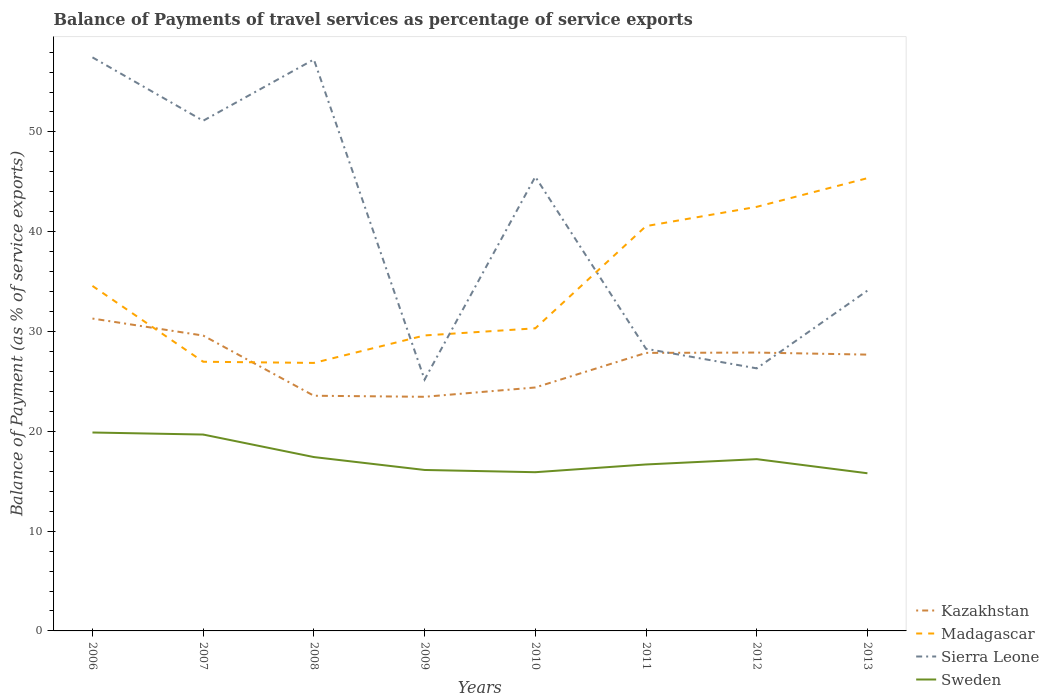How many different coloured lines are there?
Your response must be concise. 4. Across all years, what is the maximum balance of payments of travel services in Sweden?
Give a very brief answer. 15.8. What is the total balance of payments of travel services in Madagascar in the graph?
Ensure brevity in your answer.  -5.99. What is the difference between the highest and the second highest balance of payments of travel services in Kazakhstan?
Your response must be concise. 7.84. What is the difference between the highest and the lowest balance of payments of travel services in Sierra Leone?
Offer a very short reply. 4. Is the balance of payments of travel services in Sweden strictly greater than the balance of payments of travel services in Sierra Leone over the years?
Your response must be concise. Yes. How many lines are there?
Offer a very short reply. 4. What is the difference between two consecutive major ticks on the Y-axis?
Your response must be concise. 10. Are the values on the major ticks of Y-axis written in scientific E-notation?
Provide a short and direct response. No. Where does the legend appear in the graph?
Provide a succinct answer. Bottom right. How are the legend labels stacked?
Keep it short and to the point. Vertical. What is the title of the graph?
Offer a very short reply. Balance of Payments of travel services as percentage of service exports. What is the label or title of the Y-axis?
Your answer should be compact. Balance of Payment (as % of service exports). What is the Balance of Payment (as % of service exports) in Kazakhstan in 2006?
Keep it short and to the point. 31.3. What is the Balance of Payment (as % of service exports) of Madagascar in 2006?
Provide a short and direct response. 34.57. What is the Balance of Payment (as % of service exports) in Sierra Leone in 2006?
Ensure brevity in your answer.  57.47. What is the Balance of Payment (as % of service exports) in Sweden in 2006?
Give a very brief answer. 19.88. What is the Balance of Payment (as % of service exports) in Kazakhstan in 2007?
Ensure brevity in your answer.  29.6. What is the Balance of Payment (as % of service exports) of Madagascar in 2007?
Keep it short and to the point. 26.97. What is the Balance of Payment (as % of service exports) of Sierra Leone in 2007?
Your answer should be compact. 51.12. What is the Balance of Payment (as % of service exports) in Sweden in 2007?
Provide a short and direct response. 19.68. What is the Balance of Payment (as % of service exports) in Kazakhstan in 2008?
Ensure brevity in your answer.  23.57. What is the Balance of Payment (as % of service exports) of Madagascar in 2008?
Offer a terse response. 26.86. What is the Balance of Payment (as % of service exports) in Sierra Leone in 2008?
Your answer should be very brief. 57.26. What is the Balance of Payment (as % of service exports) of Sweden in 2008?
Offer a very short reply. 17.42. What is the Balance of Payment (as % of service exports) of Kazakhstan in 2009?
Your answer should be compact. 23.46. What is the Balance of Payment (as % of service exports) in Madagascar in 2009?
Offer a terse response. 29.61. What is the Balance of Payment (as % of service exports) in Sierra Leone in 2009?
Offer a very short reply. 25.19. What is the Balance of Payment (as % of service exports) of Sweden in 2009?
Your response must be concise. 16.13. What is the Balance of Payment (as % of service exports) of Kazakhstan in 2010?
Make the answer very short. 24.39. What is the Balance of Payment (as % of service exports) of Madagascar in 2010?
Keep it short and to the point. 30.32. What is the Balance of Payment (as % of service exports) of Sierra Leone in 2010?
Provide a succinct answer. 45.51. What is the Balance of Payment (as % of service exports) of Sweden in 2010?
Your answer should be very brief. 15.9. What is the Balance of Payment (as % of service exports) of Kazakhstan in 2011?
Ensure brevity in your answer.  27.86. What is the Balance of Payment (as % of service exports) in Madagascar in 2011?
Provide a short and direct response. 40.56. What is the Balance of Payment (as % of service exports) of Sierra Leone in 2011?
Your answer should be compact. 28.27. What is the Balance of Payment (as % of service exports) of Sweden in 2011?
Your answer should be very brief. 16.68. What is the Balance of Payment (as % of service exports) in Kazakhstan in 2012?
Provide a short and direct response. 27.89. What is the Balance of Payment (as % of service exports) in Madagascar in 2012?
Ensure brevity in your answer.  42.5. What is the Balance of Payment (as % of service exports) of Sierra Leone in 2012?
Give a very brief answer. 26.31. What is the Balance of Payment (as % of service exports) of Sweden in 2012?
Your answer should be compact. 17.21. What is the Balance of Payment (as % of service exports) in Kazakhstan in 2013?
Your response must be concise. 27.69. What is the Balance of Payment (as % of service exports) of Madagascar in 2013?
Keep it short and to the point. 45.37. What is the Balance of Payment (as % of service exports) of Sierra Leone in 2013?
Offer a terse response. 34.1. What is the Balance of Payment (as % of service exports) in Sweden in 2013?
Provide a short and direct response. 15.8. Across all years, what is the maximum Balance of Payment (as % of service exports) in Kazakhstan?
Offer a terse response. 31.3. Across all years, what is the maximum Balance of Payment (as % of service exports) of Madagascar?
Provide a short and direct response. 45.37. Across all years, what is the maximum Balance of Payment (as % of service exports) in Sierra Leone?
Give a very brief answer. 57.47. Across all years, what is the maximum Balance of Payment (as % of service exports) of Sweden?
Offer a terse response. 19.88. Across all years, what is the minimum Balance of Payment (as % of service exports) in Kazakhstan?
Your response must be concise. 23.46. Across all years, what is the minimum Balance of Payment (as % of service exports) of Madagascar?
Make the answer very short. 26.86. Across all years, what is the minimum Balance of Payment (as % of service exports) of Sierra Leone?
Provide a succinct answer. 25.19. Across all years, what is the minimum Balance of Payment (as % of service exports) in Sweden?
Your answer should be compact. 15.8. What is the total Balance of Payment (as % of service exports) of Kazakhstan in the graph?
Your response must be concise. 215.76. What is the total Balance of Payment (as % of service exports) in Madagascar in the graph?
Your response must be concise. 276.76. What is the total Balance of Payment (as % of service exports) in Sierra Leone in the graph?
Your answer should be compact. 325.24. What is the total Balance of Payment (as % of service exports) in Sweden in the graph?
Provide a short and direct response. 138.71. What is the difference between the Balance of Payment (as % of service exports) in Kazakhstan in 2006 and that in 2007?
Keep it short and to the point. 1.7. What is the difference between the Balance of Payment (as % of service exports) of Madagascar in 2006 and that in 2007?
Keep it short and to the point. 7.6. What is the difference between the Balance of Payment (as % of service exports) of Sierra Leone in 2006 and that in 2007?
Provide a succinct answer. 6.35. What is the difference between the Balance of Payment (as % of service exports) in Sweden in 2006 and that in 2007?
Your answer should be compact. 0.2. What is the difference between the Balance of Payment (as % of service exports) in Kazakhstan in 2006 and that in 2008?
Provide a succinct answer. 7.73. What is the difference between the Balance of Payment (as % of service exports) in Madagascar in 2006 and that in 2008?
Offer a terse response. 7.72. What is the difference between the Balance of Payment (as % of service exports) in Sierra Leone in 2006 and that in 2008?
Your response must be concise. 0.21. What is the difference between the Balance of Payment (as % of service exports) in Sweden in 2006 and that in 2008?
Offer a terse response. 2.46. What is the difference between the Balance of Payment (as % of service exports) of Kazakhstan in 2006 and that in 2009?
Provide a succinct answer. 7.84. What is the difference between the Balance of Payment (as % of service exports) of Madagascar in 2006 and that in 2009?
Your answer should be compact. 4.96. What is the difference between the Balance of Payment (as % of service exports) of Sierra Leone in 2006 and that in 2009?
Offer a terse response. 32.29. What is the difference between the Balance of Payment (as % of service exports) in Sweden in 2006 and that in 2009?
Your answer should be compact. 3.75. What is the difference between the Balance of Payment (as % of service exports) of Kazakhstan in 2006 and that in 2010?
Offer a very short reply. 6.91. What is the difference between the Balance of Payment (as % of service exports) in Madagascar in 2006 and that in 2010?
Provide a short and direct response. 4.25. What is the difference between the Balance of Payment (as % of service exports) of Sierra Leone in 2006 and that in 2010?
Offer a very short reply. 11.96. What is the difference between the Balance of Payment (as % of service exports) in Sweden in 2006 and that in 2010?
Ensure brevity in your answer.  3.98. What is the difference between the Balance of Payment (as % of service exports) of Kazakhstan in 2006 and that in 2011?
Your answer should be very brief. 3.44. What is the difference between the Balance of Payment (as % of service exports) in Madagascar in 2006 and that in 2011?
Make the answer very short. -5.99. What is the difference between the Balance of Payment (as % of service exports) in Sierra Leone in 2006 and that in 2011?
Your response must be concise. 29.2. What is the difference between the Balance of Payment (as % of service exports) in Sweden in 2006 and that in 2011?
Your response must be concise. 3.2. What is the difference between the Balance of Payment (as % of service exports) of Kazakhstan in 2006 and that in 2012?
Offer a terse response. 3.41. What is the difference between the Balance of Payment (as % of service exports) in Madagascar in 2006 and that in 2012?
Your answer should be compact. -7.92. What is the difference between the Balance of Payment (as % of service exports) in Sierra Leone in 2006 and that in 2012?
Offer a very short reply. 31.16. What is the difference between the Balance of Payment (as % of service exports) of Sweden in 2006 and that in 2012?
Keep it short and to the point. 2.67. What is the difference between the Balance of Payment (as % of service exports) in Kazakhstan in 2006 and that in 2013?
Provide a short and direct response. 3.61. What is the difference between the Balance of Payment (as % of service exports) in Madagascar in 2006 and that in 2013?
Your answer should be very brief. -10.8. What is the difference between the Balance of Payment (as % of service exports) of Sierra Leone in 2006 and that in 2013?
Offer a terse response. 23.37. What is the difference between the Balance of Payment (as % of service exports) in Sweden in 2006 and that in 2013?
Your response must be concise. 4.08. What is the difference between the Balance of Payment (as % of service exports) of Kazakhstan in 2007 and that in 2008?
Offer a terse response. 6.03. What is the difference between the Balance of Payment (as % of service exports) of Madagascar in 2007 and that in 2008?
Provide a short and direct response. 0.12. What is the difference between the Balance of Payment (as % of service exports) in Sierra Leone in 2007 and that in 2008?
Give a very brief answer. -6.14. What is the difference between the Balance of Payment (as % of service exports) in Sweden in 2007 and that in 2008?
Make the answer very short. 2.26. What is the difference between the Balance of Payment (as % of service exports) in Kazakhstan in 2007 and that in 2009?
Your answer should be very brief. 6.14. What is the difference between the Balance of Payment (as % of service exports) in Madagascar in 2007 and that in 2009?
Provide a succinct answer. -2.64. What is the difference between the Balance of Payment (as % of service exports) in Sierra Leone in 2007 and that in 2009?
Make the answer very short. 25.94. What is the difference between the Balance of Payment (as % of service exports) of Sweden in 2007 and that in 2009?
Make the answer very short. 3.55. What is the difference between the Balance of Payment (as % of service exports) in Kazakhstan in 2007 and that in 2010?
Offer a terse response. 5.2. What is the difference between the Balance of Payment (as % of service exports) of Madagascar in 2007 and that in 2010?
Keep it short and to the point. -3.35. What is the difference between the Balance of Payment (as % of service exports) in Sierra Leone in 2007 and that in 2010?
Ensure brevity in your answer.  5.61. What is the difference between the Balance of Payment (as % of service exports) of Sweden in 2007 and that in 2010?
Offer a very short reply. 3.77. What is the difference between the Balance of Payment (as % of service exports) in Kazakhstan in 2007 and that in 2011?
Ensure brevity in your answer.  1.74. What is the difference between the Balance of Payment (as % of service exports) in Madagascar in 2007 and that in 2011?
Give a very brief answer. -13.59. What is the difference between the Balance of Payment (as % of service exports) of Sierra Leone in 2007 and that in 2011?
Provide a short and direct response. 22.85. What is the difference between the Balance of Payment (as % of service exports) in Sweden in 2007 and that in 2011?
Your answer should be very brief. 3. What is the difference between the Balance of Payment (as % of service exports) of Kazakhstan in 2007 and that in 2012?
Your answer should be compact. 1.7. What is the difference between the Balance of Payment (as % of service exports) of Madagascar in 2007 and that in 2012?
Provide a short and direct response. -15.52. What is the difference between the Balance of Payment (as % of service exports) of Sierra Leone in 2007 and that in 2012?
Provide a succinct answer. 24.81. What is the difference between the Balance of Payment (as % of service exports) in Sweden in 2007 and that in 2012?
Keep it short and to the point. 2.47. What is the difference between the Balance of Payment (as % of service exports) of Kazakhstan in 2007 and that in 2013?
Offer a very short reply. 1.91. What is the difference between the Balance of Payment (as % of service exports) in Madagascar in 2007 and that in 2013?
Your response must be concise. -18.4. What is the difference between the Balance of Payment (as % of service exports) in Sierra Leone in 2007 and that in 2013?
Provide a succinct answer. 17.02. What is the difference between the Balance of Payment (as % of service exports) in Sweden in 2007 and that in 2013?
Make the answer very short. 3.88. What is the difference between the Balance of Payment (as % of service exports) of Kazakhstan in 2008 and that in 2009?
Ensure brevity in your answer.  0.11. What is the difference between the Balance of Payment (as % of service exports) of Madagascar in 2008 and that in 2009?
Provide a short and direct response. -2.75. What is the difference between the Balance of Payment (as % of service exports) in Sierra Leone in 2008 and that in 2009?
Your answer should be compact. 32.08. What is the difference between the Balance of Payment (as % of service exports) of Sweden in 2008 and that in 2009?
Your answer should be very brief. 1.29. What is the difference between the Balance of Payment (as % of service exports) of Kazakhstan in 2008 and that in 2010?
Offer a very short reply. -0.83. What is the difference between the Balance of Payment (as % of service exports) in Madagascar in 2008 and that in 2010?
Provide a succinct answer. -3.47. What is the difference between the Balance of Payment (as % of service exports) in Sierra Leone in 2008 and that in 2010?
Provide a succinct answer. 11.75. What is the difference between the Balance of Payment (as % of service exports) of Sweden in 2008 and that in 2010?
Provide a succinct answer. 1.52. What is the difference between the Balance of Payment (as % of service exports) in Kazakhstan in 2008 and that in 2011?
Your answer should be compact. -4.29. What is the difference between the Balance of Payment (as % of service exports) of Madagascar in 2008 and that in 2011?
Your answer should be compact. -13.71. What is the difference between the Balance of Payment (as % of service exports) in Sierra Leone in 2008 and that in 2011?
Give a very brief answer. 28.99. What is the difference between the Balance of Payment (as % of service exports) in Sweden in 2008 and that in 2011?
Ensure brevity in your answer.  0.74. What is the difference between the Balance of Payment (as % of service exports) in Kazakhstan in 2008 and that in 2012?
Keep it short and to the point. -4.33. What is the difference between the Balance of Payment (as % of service exports) of Madagascar in 2008 and that in 2012?
Provide a succinct answer. -15.64. What is the difference between the Balance of Payment (as % of service exports) of Sierra Leone in 2008 and that in 2012?
Your answer should be very brief. 30.95. What is the difference between the Balance of Payment (as % of service exports) of Sweden in 2008 and that in 2012?
Your response must be concise. 0.21. What is the difference between the Balance of Payment (as % of service exports) of Kazakhstan in 2008 and that in 2013?
Provide a succinct answer. -4.12. What is the difference between the Balance of Payment (as % of service exports) of Madagascar in 2008 and that in 2013?
Give a very brief answer. -18.51. What is the difference between the Balance of Payment (as % of service exports) of Sierra Leone in 2008 and that in 2013?
Provide a succinct answer. 23.16. What is the difference between the Balance of Payment (as % of service exports) in Sweden in 2008 and that in 2013?
Make the answer very short. 1.62. What is the difference between the Balance of Payment (as % of service exports) in Kazakhstan in 2009 and that in 2010?
Ensure brevity in your answer.  -0.93. What is the difference between the Balance of Payment (as % of service exports) of Madagascar in 2009 and that in 2010?
Make the answer very short. -0.71. What is the difference between the Balance of Payment (as % of service exports) of Sierra Leone in 2009 and that in 2010?
Keep it short and to the point. -20.33. What is the difference between the Balance of Payment (as % of service exports) of Sweden in 2009 and that in 2010?
Give a very brief answer. 0.22. What is the difference between the Balance of Payment (as % of service exports) of Kazakhstan in 2009 and that in 2011?
Keep it short and to the point. -4.4. What is the difference between the Balance of Payment (as % of service exports) in Madagascar in 2009 and that in 2011?
Give a very brief answer. -10.96. What is the difference between the Balance of Payment (as % of service exports) of Sierra Leone in 2009 and that in 2011?
Ensure brevity in your answer.  -3.09. What is the difference between the Balance of Payment (as % of service exports) of Sweden in 2009 and that in 2011?
Keep it short and to the point. -0.55. What is the difference between the Balance of Payment (as % of service exports) in Kazakhstan in 2009 and that in 2012?
Offer a terse response. -4.43. What is the difference between the Balance of Payment (as % of service exports) of Madagascar in 2009 and that in 2012?
Your response must be concise. -12.89. What is the difference between the Balance of Payment (as % of service exports) of Sierra Leone in 2009 and that in 2012?
Your response must be concise. -1.13. What is the difference between the Balance of Payment (as % of service exports) of Sweden in 2009 and that in 2012?
Your answer should be very brief. -1.08. What is the difference between the Balance of Payment (as % of service exports) in Kazakhstan in 2009 and that in 2013?
Give a very brief answer. -4.23. What is the difference between the Balance of Payment (as % of service exports) of Madagascar in 2009 and that in 2013?
Your answer should be very brief. -15.76. What is the difference between the Balance of Payment (as % of service exports) of Sierra Leone in 2009 and that in 2013?
Your response must be concise. -8.92. What is the difference between the Balance of Payment (as % of service exports) in Sweden in 2009 and that in 2013?
Your answer should be compact. 0.33. What is the difference between the Balance of Payment (as % of service exports) in Kazakhstan in 2010 and that in 2011?
Ensure brevity in your answer.  -3.47. What is the difference between the Balance of Payment (as % of service exports) in Madagascar in 2010 and that in 2011?
Keep it short and to the point. -10.24. What is the difference between the Balance of Payment (as % of service exports) of Sierra Leone in 2010 and that in 2011?
Ensure brevity in your answer.  17.24. What is the difference between the Balance of Payment (as % of service exports) of Sweden in 2010 and that in 2011?
Your answer should be very brief. -0.78. What is the difference between the Balance of Payment (as % of service exports) in Kazakhstan in 2010 and that in 2012?
Your response must be concise. -3.5. What is the difference between the Balance of Payment (as % of service exports) in Madagascar in 2010 and that in 2012?
Your answer should be compact. -12.17. What is the difference between the Balance of Payment (as % of service exports) in Sierra Leone in 2010 and that in 2012?
Keep it short and to the point. 19.2. What is the difference between the Balance of Payment (as % of service exports) in Sweden in 2010 and that in 2012?
Offer a very short reply. -1.31. What is the difference between the Balance of Payment (as % of service exports) of Kazakhstan in 2010 and that in 2013?
Provide a short and direct response. -3.29. What is the difference between the Balance of Payment (as % of service exports) in Madagascar in 2010 and that in 2013?
Give a very brief answer. -15.05. What is the difference between the Balance of Payment (as % of service exports) of Sierra Leone in 2010 and that in 2013?
Provide a short and direct response. 11.41. What is the difference between the Balance of Payment (as % of service exports) of Sweden in 2010 and that in 2013?
Make the answer very short. 0.11. What is the difference between the Balance of Payment (as % of service exports) in Kazakhstan in 2011 and that in 2012?
Give a very brief answer. -0.03. What is the difference between the Balance of Payment (as % of service exports) in Madagascar in 2011 and that in 2012?
Offer a very short reply. -1.93. What is the difference between the Balance of Payment (as % of service exports) in Sierra Leone in 2011 and that in 2012?
Give a very brief answer. 1.96. What is the difference between the Balance of Payment (as % of service exports) of Sweden in 2011 and that in 2012?
Your response must be concise. -0.53. What is the difference between the Balance of Payment (as % of service exports) in Kazakhstan in 2011 and that in 2013?
Give a very brief answer. 0.17. What is the difference between the Balance of Payment (as % of service exports) in Madagascar in 2011 and that in 2013?
Provide a succinct answer. -4.8. What is the difference between the Balance of Payment (as % of service exports) of Sierra Leone in 2011 and that in 2013?
Offer a terse response. -5.83. What is the difference between the Balance of Payment (as % of service exports) in Sweden in 2011 and that in 2013?
Keep it short and to the point. 0.88. What is the difference between the Balance of Payment (as % of service exports) of Kazakhstan in 2012 and that in 2013?
Your answer should be very brief. 0.21. What is the difference between the Balance of Payment (as % of service exports) in Madagascar in 2012 and that in 2013?
Offer a terse response. -2.87. What is the difference between the Balance of Payment (as % of service exports) in Sierra Leone in 2012 and that in 2013?
Your response must be concise. -7.79. What is the difference between the Balance of Payment (as % of service exports) of Sweden in 2012 and that in 2013?
Make the answer very short. 1.41. What is the difference between the Balance of Payment (as % of service exports) of Kazakhstan in 2006 and the Balance of Payment (as % of service exports) of Madagascar in 2007?
Offer a terse response. 4.33. What is the difference between the Balance of Payment (as % of service exports) of Kazakhstan in 2006 and the Balance of Payment (as % of service exports) of Sierra Leone in 2007?
Offer a very short reply. -19.82. What is the difference between the Balance of Payment (as % of service exports) in Kazakhstan in 2006 and the Balance of Payment (as % of service exports) in Sweden in 2007?
Offer a very short reply. 11.62. What is the difference between the Balance of Payment (as % of service exports) in Madagascar in 2006 and the Balance of Payment (as % of service exports) in Sierra Leone in 2007?
Your answer should be compact. -16.55. What is the difference between the Balance of Payment (as % of service exports) of Madagascar in 2006 and the Balance of Payment (as % of service exports) of Sweden in 2007?
Provide a succinct answer. 14.89. What is the difference between the Balance of Payment (as % of service exports) in Sierra Leone in 2006 and the Balance of Payment (as % of service exports) in Sweden in 2007?
Your response must be concise. 37.79. What is the difference between the Balance of Payment (as % of service exports) in Kazakhstan in 2006 and the Balance of Payment (as % of service exports) in Madagascar in 2008?
Give a very brief answer. 4.45. What is the difference between the Balance of Payment (as % of service exports) in Kazakhstan in 2006 and the Balance of Payment (as % of service exports) in Sierra Leone in 2008?
Ensure brevity in your answer.  -25.96. What is the difference between the Balance of Payment (as % of service exports) of Kazakhstan in 2006 and the Balance of Payment (as % of service exports) of Sweden in 2008?
Offer a very short reply. 13.88. What is the difference between the Balance of Payment (as % of service exports) in Madagascar in 2006 and the Balance of Payment (as % of service exports) in Sierra Leone in 2008?
Make the answer very short. -22.69. What is the difference between the Balance of Payment (as % of service exports) in Madagascar in 2006 and the Balance of Payment (as % of service exports) in Sweden in 2008?
Your response must be concise. 17.15. What is the difference between the Balance of Payment (as % of service exports) in Sierra Leone in 2006 and the Balance of Payment (as % of service exports) in Sweden in 2008?
Your response must be concise. 40.05. What is the difference between the Balance of Payment (as % of service exports) in Kazakhstan in 2006 and the Balance of Payment (as % of service exports) in Madagascar in 2009?
Give a very brief answer. 1.69. What is the difference between the Balance of Payment (as % of service exports) of Kazakhstan in 2006 and the Balance of Payment (as % of service exports) of Sierra Leone in 2009?
Your answer should be compact. 6.12. What is the difference between the Balance of Payment (as % of service exports) in Kazakhstan in 2006 and the Balance of Payment (as % of service exports) in Sweden in 2009?
Your answer should be very brief. 15.17. What is the difference between the Balance of Payment (as % of service exports) of Madagascar in 2006 and the Balance of Payment (as % of service exports) of Sierra Leone in 2009?
Provide a short and direct response. 9.39. What is the difference between the Balance of Payment (as % of service exports) of Madagascar in 2006 and the Balance of Payment (as % of service exports) of Sweden in 2009?
Offer a very short reply. 18.44. What is the difference between the Balance of Payment (as % of service exports) in Sierra Leone in 2006 and the Balance of Payment (as % of service exports) in Sweden in 2009?
Your answer should be compact. 41.34. What is the difference between the Balance of Payment (as % of service exports) of Kazakhstan in 2006 and the Balance of Payment (as % of service exports) of Madagascar in 2010?
Your response must be concise. 0.98. What is the difference between the Balance of Payment (as % of service exports) in Kazakhstan in 2006 and the Balance of Payment (as % of service exports) in Sierra Leone in 2010?
Ensure brevity in your answer.  -14.21. What is the difference between the Balance of Payment (as % of service exports) in Kazakhstan in 2006 and the Balance of Payment (as % of service exports) in Sweden in 2010?
Offer a very short reply. 15.4. What is the difference between the Balance of Payment (as % of service exports) of Madagascar in 2006 and the Balance of Payment (as % of service exports) of Sierra Leone in 2010?
Offer a very short reply. -10.94. What is the difference between the Balance of Payment (as % of service exports) of Madagascar in 2006 and the Balance of Payment (as % of service exports) of Sweden in 2010?
Provide a short and direct response. 18.67. What is the difference between the Balance of Payment (as % of service exports) in Sierra Leone in 2006 and the Balance of Payment (as % of service exports) in Sweden in 2010?
Keep it short and to the point. 41.57. What is the difference between the Balance of Payment (as % of service exports) in Kazakhstan in 2006 and the Balance of Payment (as % of service exports) in Madagascar in 2011?
Offer a very short reply. -9.26. What is the difference between the Balance of Payment (as % of service exports) in Kazakhstan in 2006 and the Balance of Payment (as % of service exports) in Sierra Leone in 2011?
Your answer should be very brief. 3.03. What is the difference between the Balance of Payment (as % of service exports) of Kazakhstan in 2006 and the Balance of Payment (as % of service exports) of Sweden in 2011?
Provide a succinct answer. 14.62. What is the difference between the Balance of Payment (as % of service exports) of Madagascar in 2006 and the Balance of Payment (as % of service exports) of Sierra Leone in 2011?
Offer a terse response. 6.3. What is the difference between the Balance of Payment (as % of service exports) of Madagascar in 2006 and the Balance of Payment (as % of service exports) of Sweden in 2011?
Offer a very short reply. 17.89. What is the difference between the Balance of Payment (as % of service exports) of Sierra Leone in 2006 and the Balance of Payment (as % of service exports) of Sweden in 2011?
Your answer should be compact. 40.79. What is the difference between the Balance of Payment (as % of service exports) in Kazakhstan in 2006 and the Balance of Payment (as % of service exports) in Madagascar in 2012?
Offer a very short reply. -11.19. What is the difference between the Balance of Payment (as % of service exports) of Kazakhstan in 2006 and the Balance of Payment (as % of service exports) of Sierra Leone in 2012?
Ensure brevity in your answer.  4.99. What is the difference between the Balance of Payment (as % of service exports) of Kazakhstan in 2006 and the Balance of Payment (as % of service exports) of Sweden in 2012?
Your answer should be compact. 14.09. What is the difference between the Balance of Payment (as % of service exports) in Madagascar in 2006 and the Balance of Payment (as % of service exports) in Sierra Leone in 2012?
Your answer should be very brief. 8.26. What is the difference between the Balance of Payment (as % of service exports) in Madagascar in 2006 and the Balance of Payment (as % of service exports) in Sweden in 2012?
Provide a succinct answer. 17.36. What is the difference between the Balance of Payment (as % of service exports) of Sierra Leone in 2006 and the Balance of Payment (as % of service exports) of Sweden in 2012?
Give a very brief answer. 40.26. What is the difference between the Balance of Payment (as % of service exports) in Kazakhstan in 2006 and the Balance of Payment (as % of service exports) in Madagascar in 2013?
Give a very brief answer. -14.07. What is the difference between the Balance of Payment (as % of service exports) in Kazakhstan in 2006 and the Balance of Payment (as % of service exports) in Sierra Leone in 2013?
Provide a succinct answer. -2.8. What is the difference between the Balance of Payment (as % of service exports) in Kazakhstan in 2006 and the Balance of Payment (as % of service exports) in Sweden in 2013?
Keep it short and to the point. 15.5. What is the difference between the Balance of Payment (as % of service exports) in Madagascar in 2006 and the Balance of Payment (as % of service exports) in Sierra Leone in 2013?
Make the answer very short. 0.47. What is the difference between the Balance of Payment (as % of service exports) of Madagascar in 2006 and the Balance of Payment (as % of service exports) of Sweden in 2013?
Your response must be concise. 18.77. What is the difference between the Balance of Payment (as % of service exports) of Sierra Leone in 2006 and the Balance of Payment (as % of service exports) of Sweden in 2013?
Make the answer very short. 41.67. What is the difference between the Balance of Payment (as % of service exports) of Kazakhstan in 2007 and the Balance of Payment (as % of service exports) of Madagascar in 2008?
Make the answer very short. 2.74. What is the difference between the Balance of Payment (as % of service exports) of Kazakhstan in 2007 and the Balance of Payment (as % of service exports) of Sierra Leone in 2008?
Make the answer very short. -27.66. What is the difference between the Balance of Payment (as % of service exports) of Kazakhstan in 2007 and the Balance of Payment (as % of service exports) of Sweden in 2008?
Give a very brief answer. 12.18. What is the difference between the Balance of Payment (as % of service exports) in Madagascar in 2007 and the Balance of Payment (as % of service exports) in Sierra Leone in 2008?
Provide a short and direct response. -30.29. What is the difference between the Balance of Payment (as % of service exports) of Madagascar in 2007 and the Balance of Payment (as % of service exports) of Sweden in 2008?
Keep it short and to the point. 9.55. What is the difference between the Balance of Payment (as % of service exports) in Sierra Leone in 2007 and the Balance of Payment (as % of service exports) in Sweden in 2008?
Provide a short and direct response. 33.7. What is the difference between the Balance of Payment (as % of service exports) of Kazakhstan in 2007 and the Balance of Payment (as % of service exports) of Madagascar in 2009?
Offer a very short reply. -0.01. What is the difference between the Balance of Payment (as % of service exports) of Kazakhstan in 2007 and the Balance of Payment (as % of service exports) of Sierra Leone in 2009?
Make the answer very short. 4.41. What is the difference between the Balance of Payment (as % of service exports) of Kazakhstan in 2007 and the Balance of Payment (as % of service exports) of Sweden in 2009?
Your answer should be very brief. 13.47. What is the difference between the Balance of Payment (as % of service exports) of Madagascar in 2007 and the Balance of Payment (as % of service exports) of Sierra Leone in 2009?
Provide a short and direct response. 1.79. What is the difference between the Balance of Payment (as % of service exports) of Madagascar in 2007 and the Balance of Payment (as % of service exports) of Sweden in 2009?
Offer a very short reply. 10.84. What is the difference between the Balance of Payment (as % of service exports) in Sierra Leone in 2007 and the Balance of Payment (as % of service exports) in Sweden in 2009?
Your answer should be compact. 34.99. What is the difference between the Balance of Payment (as % of service exports) in Kazakhstan in 2007 and the Balance of Payment (as % of service exports) in Madagascar in 2010?
Ensure brevity in your answer.  -0.73. What is the difference between the Balance of Payment (as % of service exports) of Kazakhstan in 2007 and the Balance of Payment (as % of service exports) of Sierra Leone in 2010?
Give a very brief answer. -15.91. What is the difference between the Balance of Payment (as % of service exports) of Kazakhstan in 2007 and the Balance of Payment (as % of service exports) of Sweden in 2010?
Give a very brief answer. 13.69. What is the difference between the Balance of Payment (as % of service exports) in Madagascar in 2007 and the Balance of Payment (as % of service exports) in Sierra Leone in 2010?
Offer a very short reply. -18.54. What is the difference between the Balance of Payment (as % of service exports) of Madagascar in 2007 and the Balance of Payment (as % of service exports) of Sweden in 2010?
Keep it short and to the point. 11.07. What is the difference between the Balance of Payment (as % of service exports) of Sierra Leone in 2007 and the Balance of Payment (as % of service exports) of Sweden in 2010?
Offer a terse response. 35.22. What is the difference between the Balance of Payment (as % of service exports) in Kazakhstan in 2007 and the Balance of Payment (as % of service exports) in Madagascar in 2011?
Your answer should be compact. -10.97. What is the difference between the Balance of Payment (as % of service exports) in Kazakhstan in 2007 and the Balance of Payment (as % of service exports) in Sierra Leone in 2011?
Your answer should be compact. 1.33. What is the difference between the Balance of Payment (as % of service exports) of Kazakhstan in 2007 and the Balance of Payment (as % of service exports) of Sweden in 2011?
Provide a short and direct response. 12.92. What is the difference between the Balance of Payment (as % of service exports) in Madagascar in 2007 and the Balance of Payment (as % of service exports) in Sierra Leone in 2011?
Offer a very short reply. -1.3. What is the difference between the Balance of Payment (as % of service exports) of Madagascar in 2007 and the Balance of Payment (as % of service exports) of Sweden in 2011?
Offer a very short reply. 10.29. What is the difference between the Balance of Payment (as % of service exports) in Sierra Leone in 2007 and the Balance of Payment (as % of service exports) in Sweden in 2011?
Your response must be concise. 34.44. What is the difference between the Balance of Payment (as % of service exports) of Kazakhstan in 2007 and the Balance of Payment (as % of service exports) of Madagascar in 2012?
Keep it short and to the point. -12.9. What is the difference between the Balance of Payment (as % of service exports) of Kazakhstan in 2007 and the Balance of Payment (as % of service exports) of Sierra Leone in 2012?
Give a very brief answer. 3.29. What is the difference between the Balance of Payment (as % of service exports) in Kazakhstan in 2007 and the Balance of Payment (as % of service exports) in Sweden in 2012?
Your answer should be very brief. 12.38. What is the difference between the Balance of Payment (as % of service exports) of Madagascar in 2007 and the Balance of Payment (as % of service exports) of Sierra Leone in 2012?
Make the answer very short. 0.66. What is the difference between the Balance of Payment (as % of service exports) in Madagascar in 2007 and the Balance of Payment (as % of service exports) in Sweden in 2012?
Your answer should be very brief. 9.76. What is the difference between the Balance of Payment (as % of service exports) of Sierra Leone in 2007 and the Balance of Payment (as % of service exports) of Sweden in 2012?
Ensure brevity in your answer.  33.91. What is the difference between the Balance of Payment (as % of service exports) of Kazakhstan in 2007 and the Balance of Payment (as % of service exports) of Madagascar in 2013?
Your answer should be compact. -15.77. What is the difference between the Balance of Payment (as % of service exports) of Kazakhstan in 2007 and the Balance of Payment (as % of service exports) of Sierra Leone in 2013?
Your response must be concise. -4.5. What is the difference between the Balance of Payment (as % of service exports) of Kazakhstan in 2007 and the Balance of Payment (as % of service exports) of Sweden in 2013?
Make the answer very short. 13.8. What is the difference between the Balance of Payment (as % of service exports) in Madagascar in 2007 and the Balance of Payment (as % of service exports) in Sierra Leone in 2013?
Your answer should be compact. -7.13. What is the difference between the Balance of Payment (as % of service exports) of Madagascar in 2007 and the Balance of Payment (as % of service exports) of Sweden in 2013?
Make the answer very short. 11.17. What is the difference between the Balance of Payment (as % of service exports) in Sierra Leone in 2007 and the Balance of Payment (as % of service exports) in Sweden in 2013?
Provide a short and direct response. 35.32. What is the difference between the Balance of Payment (as % of service exports) in Kazakhstan in 2008 and the Balance of Payment (as % of service exports) in Madagascar in 2009?
Make the answer very short. -6.04. What is the difference between the Balance of Payment (as % of service exports) of Kazakhstan in 2008 and the Balance of Payment (as % of service exports) of Sierra Leone in 2009?
Ensure brevity in your answer.  -1.62. What is the difference between the Balance of Payment (as % of service exports) of Kazakhstan in 2008 and the Balance of Payment (as % of service exports) of Sweden in 2009?
Offer a terse response. 7.44. What is the difference between the Balance of Payment (as % of service exports) in Madagascar in 2008 and the Balance of Payment (as % of service exports) in Sierra Leone in 2009?
Provide a short and direct response. 1.67. What is the difference between the Balance of Payment (as % of service exports) in Madagascar in 2008 and the Balance of Payment (as % of service exports) in Sweden in 2009?
Your answer should be compact. 10.73. What is the difference between the Balance of Payment (as % of service exports) of Sierra Leone in 2008 and the Balance of Payment (as % of service exports) of Sweden in 2009?
Offer a terse response. 41.13. What is the difference between the Balance of Payment (as % of service exports) of Kazakhstan in 2008 and the Balance of Payment (as % of service exports) of Madagascar in 2010?
Give a very brief answer. -6.76. What is the difference between the Balance of Payment (as % of service exports) in Kazakhstan in 2008 and the Balance of Payment (as % of service exports) in Sierra Leone in 2010?
Your answer should be compact. -21.94. What is the difference between the Balance of Payment (as % of service exports) in Kazakhstan in 2008 and the Balance of Payment (as % of service exports) in Sweden in 2010?
Give a very brief answer. 7.66. What is the difference between the Balance of Payment (as % of service exports) in Madagascar in 2008 and the Balance of Payment (as % of service exports) in Sierra Leone in 2010?
Give a very brief answer. -18.66. What is the difference between the Balance of Payment (as % of service exports) of Madagascar in 2008 and the Balance of Payment (as % of service exports) of Sweden in 2010?
Offer a terse response. 10.95. What is the difference between the Balance of Payment (as % of service exports) in Sierra Leone in 2008 and the Balance of Payment (as % of service exports) in Sweden in 2010?
Keep it short and to the point. 41.36. What is the difference between the Balance of Payment (as % of service exports) of Kazakhstan in 2008 and the Balance of Payment (as % of service exports) of Madagascar in 2011?
Provide a short and direct response. -17. What is the difference between the Balance of Payment (as % of service exports) of Kazakhstan in 2008 and the Balance of Payment (as % of service exports) of Sierra Leone in 2011?
Provide a short and direct response. -4.7. What is the difference between the Balance of Payment (as % of service exports) of Kazakhstan in 2008 and the Balance of Payment (as % of service exports) of Sweden in 2011?
Give a very brief answer. 6.89. What is the difference between the Balance of Payment (as % of service exports) of Madagascar in 2008 and the Balance of Payment (as % of service exports) of Sierra Leone in 2011?
Give a very brief answer. -1.42. What is the difference between the Balance of Payment (as % of service exports) of Madagascar in 2008 and the Balance of Payment (as % of service exports) of Sweden in 2011?
Make the answer very short. 10.18. What is the difference between the Balance of Payment (as % of service exports) of Sierra Leone in 2008 and the Balance of Payment (as % of service exports) of Sweden in 2011?
Make the answer very short. 40.58. What is the difference between the Balance of Payment (as % of service exports) of Kazakhstan in 2008 and the Balance of Payment (as % of service exports) of Madagascar in 2012?
Your response must be concise. -18.93. What is the difference between the Balance of Payment (as % of service exports) of Kazakhstan in 2008 and the Balance of Payment (as % of service exports) of Sierra Leone in 2012?
Provide a succinct answer. -2.75. What is the difference between the Balance of Payment (as % of service exports) in Kazakhstan in 2008 and the Balance of Payment (as % of service exports) in Sweden in 2012?
Ensure brevity in your answer.  6.35. What is the difference between the Balance of Payment (as % of service exports) of Madagascar in 2008 and the Balance of Payment (as % of service exports) of Sierra Leone in 2012?
Provide a succinct answer. 0.54. What is the difference between the Balance of Payment (as % of service exports) of Madagascar in 2008 and the Balance of Payment (as % of service exports) of Sweden in 2012?
Give a very brief answer. 9.64. What is the difference between the Balance of Payment (as % of service exports) in Sierra Leone in 2008 and the Balance of Payment (as % of service exports) in Sweden in 2012?
Provide a short and direct response. 40.05. What is the difference between the Balance of Payment (as % of service exports) of Kazakhstan in 2008 and the Balance of Payment (as % of service exports) of Madagascar in 2013?
Give a very brief answer. -21.8. What is the difference between the Balance of Payment (as % of service exports) of Kazakhstan in 2008 and the Balance of Payment (as % of service exports) of Sierra Leone in 2013?
Your response must be concise. -10.54. What is the difference between the Balance of Payment (as % of service exports) in Kazakhstan in 2008 and the Balance of Payment (as % of service exports) in Sweden in 2013?
Provide a short and direct response. 7.77. What is the difference between the Balance of Payment (as % of service exports) of Madagascar in 2008 and the Balance of Payment (as % of service exports) of Sierra Leone in 2013?
Your answer should be compact. -7.25. What is the difference between the Balance of Payment (as % of service exports) of Madagascar in 2008 and the Balance of Payment (as % of service exports) of Sweden in 2013?
Offer a terse response. 11.06. What is the difference between the Balance of Payment (as % of service exports) of Sierra Leone in 2008 and the Balance of Payment (as % of service exports) of Sweden in 2013?
Keep it short and to the point. 41.46. What is the difference between the Balance of Payment (as % of service exports) of Kazakhstan in 2009 and the Balance of Payment (as % of service exports) of Madagascar in 2010?
Provide a succinct answer. -6.86. What is the difference between the Balance of Payment (as % of service exports) in Kazakhstan in 2009 and the Balance of Payment (as % of service exports) in Sierra Leone in 2010?
Ensure brevity in your answer.  -22.05. What is the difference between the Balance of Payment (as % of service exports) of Kazakhstan in 2009 and the Balance of Payment (as % of service exports) of Sweden in 2010?
Give a very brief answer. 7.56. What is the difference between the Balance of Payment (as % of service exports) in Madagascar in 2009 and the Balance of Payment (as % of service exports) in Sierra Leone in 2010?
Your answer should be very brief. -15.9. What is the difference between the Balance of Payment (as % of service exports) in Madagascar in 2009 and the Balance of Payment (as % of service exports) in Sweden in 2010?
Ensure brevity in your answer.  13.7. What is the difference between the Balance of Payment (as % of service exports) of Sierra Leone in 2009 and the Balance of Payment (as % of service exports) of Sweden in 2010?
Your response must be concise. 9.28. What is the difference between the Balance of Payment (as % of service exports) of Kazakhstan in 2009 and the Balance of Payment (as % of service exports) of Madagascar in 2011?
Your answer should be compact. -17.1. What is the difference between the Balance of Payment (as % of service exports) in Kazakhstan in 2009 and the Balance of Payment (as % of service exports) in Sierra Leone in 2011?
Your answer should be very brief. -4.81. What is the difference between the Balance of Payment (as % of service exports) in Kazakhstan in 2009 and the Balance of Payment (as % of service exports) in Sweden in 2011?
Your response must be concise. 6.78. What is the difference between the Balance of Payment (as % of service exports) of Madagascar in 2009 and the Balance of Payment (as % of service exports) of Sierra Leone in 2011?
Your answer should be very brief. 1.34. What is the difference between the Balance of Payment (as % of service exports) of Madagascar in 2009 and the Balance of Payment (as % of service exports) of Sweden in 2011?
Give a very brief answer. 12.93. What is the difference between the Balance of Payment (as % of service exports) of Sierra Leone in 2009 and the Balance of Payment (as % of service exports) of Sweden in 2011?
Offer a very short reply. 8.51. What is the difference between the Balance of Payment (as % of service exports) of Kazakhstan in 2009 and the Balance of Payment (as % of service exports) of Madagascar in 2012?
Your answer should be very brief. -19.03. What is the difference between the Balance of Payment (as % of service exports) in Kazakhstan in 2009 and the Balance of Payment (as % of service exports) in Sierra Leone in 2012?
Offer a terse response. -2.85. What is the difference between the Balance of Payment (as % of service exports) of Kazakhstan in 2009 and the Balance of Payment (as % of service exports) of Sweden in 2012?
Provide a succinct answer. 6.25. What is the difference between the Balance of Payment (as % of service exports) of Madagascar in 2009 and the Balance of Payment (as % of service exports) of Sierra Leone in 2012?
Ensure brevity in your answer.  3.3. What is the difference between the Balance of Payment (as % of service exports) in Madagascar in 2009 and the Balance of Payment (as % of service exports) in Sweden in 2012?
Ensure brevity in your answer.  12.4. What is the difference between the Balance of Payment (as % of service exports) of Sierra Leone in 2009 and the Balance of Payment (as % of service exports) of Sweden in 2012?
Ensure brevity in your answer.  7.97. What is the difference between the Balance of Payment (as % of service exports) of Kazakhstan in 2009 and the Balance of Payment (as % of service exports) of Madagascar in 2013?
Offer a very short reply. -21.91. What is the difference between the Balance of Payment (as % of service exports) in Kazakhstan in 2009 and the Balance of Payment (as % of service exports) in Sierra Leone in 2013?
Offer a terse response. -10.64. What is the difference between the Balance of Payment (as % of service exports) of Kazakhstan in 2009 and the Balance of Payment (as % of service exports) of Sweden in 2013?
Offer a very short reply. 7.66. What is the difference between the Balance of Payment (as % of service exports) in Madagascar in 2009 and the Balance of Payment (as % of service exports) in Sierra Leone in 2013?
Your response must be concise. -4.49. What is the difference between the Balance of Payment (as % of service exports) of Madagascar in 2009 and the Balance of Payment (as % of service exports) of Sweden in 2013?
Provide a short and direct response. 13.81. What is the difference between the Balance of Payment (as % of service exports) in Sierra Leone in 2009 and the Balance of Payment (as % of service exports) in Sweden in 2013?
Your answer should be compact. 9.39. What is the difference between the Balance of Payment (as % of service exports) in Kazakhstan in 2010 and the Balance of Payment (as % of service exports) in Madagascar in 2011?
Keep it short and to the point. -16.17. What is the difference between the Balance of Payment (as % of service exports) of Kazakhstan in 2010 and the Balance of Payment (as % of service exports) of Sierra Leone in 2011?
Give a very brief answer. -3.88. What is the difference between the Balance of Payment (as % of service exports) in Kazakhstan in 2010 and the Balance of Payment (as % of service exports) in Sweden in 2011?
Provide a succinct answer. 7.71. What is the difference between the Balance of Payment (as % of service exports) in Madagascar in 2010 and the Balance of Payment (as % of service exports) in Sierra Leone in 2011?
Your answer should be compact. 2.05. What is the difference between the Balance of Payment (as % of service exports) in Madagascar in 2010 and the Balance of Payment (as % of service exports) in Sweden in 2011?
Provide a succinct answer. 13.64. What is the difference between the Balance of Payment (as % of service exports) of Sierra Leone in 2010 and the Balance of Payment (as % of service exports) of Sweden in 2011?
Give a very brief answer. 28.83. What is the difference between the Balance of Payment (as % of service exports) of Kazakhstan in 2010 and the Balance of Payment (as % of service exports) of Madagascar in 2012?
Ensure brevity in your answer.  -18.1. What is the difference between the Balance of Payment (as % of service exports) in Kazakhstan in 2010 and the Balance of Payment (as % of service exports) in Sierra Leone in 2012?
Keep it short and to the point. -1.92. What is the difference between the Balance of Payment (as % of service exports) of Kazakhstan in 2010 and the Balance of Payment (as % of service exports) of Sweden in 2012?
Ensure brevity in your answer.  7.18. What is the difference between the Balance of Payment (as % of service exports) in Madagascar in 2010 and the Balance of Payment (as % of service exports) in Sierra Leone in 2012?
Provide a short and direct response. 4.01. What is the difference between the Balance of Payment (as % of service exports) of Madagascar in 2010 and the Balance of Payment (as % of service exports) of Sweden in 2012?
Provide a short and direct response. 13.11. What is the difference between the Balance of Payment (as % of service exports) of Sierra Leone in 2010 and the Balance of Payment (as % of service exports) of Sweden in 2012?
Your answer should be compact. 28.3. What is the difference between the Balance of Payment (as % of service exports) of Kazakhstan in 2010 and the Balance of Payment (as % of service exports) of Madagascar in 2013?
Your answer should be compact. -20.97. What is the difference between the Balance of Payment (as % of service exports) in Kazakhstan in 2010 and the Balance of Payment (as % of service exports) in Sierra Leone in 2013?
Keep it short and to the point. -9.71. What is the difference between the Balance of Payment (as % of service exports) in Kazakhstan in 2010 and the Balance of Payment (as % of service exports) in Sweden in 2013?
Keep it short and to the point. 8.6. What is the difference between the Balance of Payment (as % of service exports) of Madagascar in 2010 and the Balance of Payment (as % of service exports) of Sierra Leone in 2013?
Your answer should be compact. -3.78. What is the difference between the Balance of Payment (as % of service exports) in Madagascar in 2010 and the Balance of Payment (as % of service exports) in Sweden in 2013?
Keep it short and to the point. 14.52. What is the difference between the Balance of Payment (as % of service exports) in Sierra Leone in 2010 and the Balance of Payment (as % of service exports) in Sweden in 2013?
Ensure brevity in your answer.  29.71. What is the difference between the Balance of Payment (as % of service exports) of Kazakhstan in 2011 and the Balance of Payment (as % of service exports) of Madagascar in 2012?
Offer a very short reply. -14.64. What is the difference between the Balance of Payment (as % of service exports) in Kazakhstan in 2011 and the Balance of Payment (as % of service exports) in Sierra Leone in 2012?
Provide a short and direct response. 1.55. What is the difference between the Balance of Payment (as % of service exports) of Kazakhstan in 2011 and the Balance of Payment (as % of service exports) of Sweden in 2012?
Provide a short and direct response. 10.65. What is the difference between the Balance of Payment (as % of service exports) of Madagascar in 2011 and the Balance of Payment (as % of service exports) of Sierra Leone in 2012?
Your response must be concise. 14.25. What is the difference between the Balance of Payment (as % of service exports) in Madagascar in 2011 and the Balance of Payment (as % of service exports) in Sweden in 2012?
Provide a succinct answer. 23.35. What is the difference between the Balance of Payment (as % of service exports) in Sierra Leone in 2011 and the Balance of Payment (as % of service exports) in Sweden in 2012?
Make the answer very short. 11.06. What is the difference between the Balance of Payment (as % of service exports) of Kazakhstan in 2011 and the Balance of Payment (as % of service exports) of Madagascar in 2013?
Make the answer very short. -17.51. What is the difference between the Balance of Payment (as % of service exports) of Kazakhstan in 2011 and the Balance of Payment (as % of service exports) of Sierra Leone in 2013?
Give a very brief answer. -6.24. What is the difference between the Balance of Payment (as % of service exports) in Kazakhstan in 2011 and the Balance of Payment (as % of service exports) in Sweden in 2013?
Keep it short and to the point. 12.06. What is the difference between the Balance of Payment (as % of service exports) of Madagascar in 2011 and the Balance of Payment (as % of service exports) of Sierra Leone in 2013?
Keep it short and to the point. 6.46. What is the difference between the Balance of Payment (as % of service exports) of Madagascar in 2011 and the Balance of Payment (as % of service exports) of Sweden in 2013?
Provide a short and direct response. 24.77. What is the difference between the Balance of Payment (as % of service exports) in Sierra Leone in 2011 and the Balance of Payment (as % of service exports) in Sweden in 2013?
Ensure brevity in your answer.  12.47. What is the difference between the Balance of Payment (as % of service exports) in Kazakhstan in 2012 and the Balance of Payment (as % of service exports) in Madagascar in 2013?
Provide a short and direct response. -17.48. What is the difference between the Balance of Payment (as % of service exports) of Kazakhstan in 2012 and the Balance of Payment (as % of service exports) of Sierra Leone in 2013?
Offer a terse response. -6.21. What is the difference between the Balance of Payment (as % of service exports) of Kazakhstan in 2012 and the Balance of Payment (as % of service exports) of Sweden in 2013?
Make the answer very short. 12.09. What is the difference between the Balance of Payment (as % of service exports) in Madagascar in 2012 and the Balance of Payment (as % of service exports) in Sierra Leone in 2013?
Your answer should be compact. 8.39. What is the difference between the Balance of Payment (as % of service exports) in Madagascar in 2012 and the Balance of Payment (as % of service exports) in Sweden in 2013?
Provide a succinct answer. 26.7. What is the difference between the Balance of Payment (as % of service exports) in Sierra Leone in 2012 and the Balance of Payment (as % of service exports) in Sweden in 2013?
Make the answer very short. 10.51. What is the average Balance of Payment (as % of service exports) in Kazakhstan per year?
Your response must be concise. 26.97. What is the average Balance of Payment (as % of service exports) in Madagascar per year?
Keep it short and to the point. 34.59. What is the average Balance of Payment (as % of service exports) of Sierra Leone per year?
Ensure brevity in your answer.  40.65. What is the average Balance of Payment (as % of service exports) in Sweden per year?
Your response must be concise. 17.34. In the year 2006, what is the difference between the Balance of Payment (as % of service exports) in Kazakhstan and Balance of Payment (as % of service exports) in Madagascar?
Offer a terse response. -3.27. In the year 2006, what is the difference between the Balance of Payment (as % of service exports) of Kazakhstan and Balance of Payment (as % of service exports) of Sierra Leone?
Provide a succinct answer. -26.17. In the year 2006, what is the difference between the Balance of Payment (as % of service exports) in Kazakhstan and Balance of Payment (as % of service exports) in Sweden?
Provide a succinct answer. 11.42. In the year 2006, what is the difference between the Balance of Payment (as % of service exports) of Madagascar and Balance of Payment (as % of service exports) of Sierra Leone?
Provide a succinct answer. -22.9. In the year 2006, what is the difference between the Balance of Payment (as % of service exports) in Madagascar and Balance of Payment (as % of service exports) in Sweden?
Give a very brief answer. 14.69. In the year 2006, what is the difference between the Balance of Payment (as % of service exports) in Sierra Leone and Balance of Payment (as % of service exports) in Sweden?
Your response must be concise. 37.59. In the year 2007, what is the difference between the Balance of Payment (as % of service exports) in Kazakhstan and Balance of Payment (as % of service exports) in Madagascar?
Make the answer very short. 2.62. In the year 2007, what is the difference between the Balance of Payment (as % of service exports) in Kazakhstan and Balance of Payment (as % of service exports) in Sierra Leone?
Give a very brief answer. -21.52. In the year 2007, what is the difference between the Balance of Payment (as % of service exports) in Kazakhstan and Balance of Payment (as % of service exports) in Sweden?
Your answer should be compact. 9.92. In the year 2007, what is the difference between the Balance of Payment (as % of service exports) in Madagascar and Balance of Payment (as % of service exports) in Sierra Leone?
Ensure brevity in your answer.  -24.15. In the year 2007, what is the difference between the Balance of Payment (as % of service exports) in Madagascar and Balance of Payment (as % of service exports) in Sweden?
Offer a very short reply. 7.29. In the year 2007, what is the difference between the Balance of Payment (as % of service exports) in Sierra Leone and Balance of Payment (as % of service exports) in Sweden?
Your answer should be compact. 31.44. In the year 2008, what is the difference between the Balance of Payment (as % of service exports) in Kazakhstan and Balance of Payment (as % of service exports) in Madagascar?
Provide a short and direct response. -3.29. In the year 2008, what is the difference between the Balance of Payment (as % of service exports) of Kazakhstan and Balance of Payment (as % of service exports) of Sierra Leone?
Offer a terse response. -33.69. In the year 2008, what is the difference between the Balance of Payment (as % of service exports) of Kazakhstan and Balance of Payment (as % of service exports) of Sweden?
Offer a very short reply. 6.15. In the year 2008, what is the difference between the Balance of Payment (as % of service exports) in Madagascar and Balance of Payment (as % of service exports) in Sierra Leone?
Keep it short and to the point. -30.41. In the year 2008, what is the difference between the Balance of Payment (as % of service exports) of Madagascar and Balance of Payment (as % of service exports) of Sweden?
Your answer should be very brief. 9.43. In the year 2008, what is the difference between the Balance of Payment (as % of service exports) of Sierra Leone and Balance of Payment (as % of service exports) of Sweden?
Your answer should be compact. 39.84. In the year 2009, what is the difference between the Balance of Payment (as % of service exports) in Kazakhstan and Balance of Payment (as % of service exports) in Madagascar?
Ensure brevity in your answer.  -6.15. In the year 2009, what is the difference between the Balance of Payment (as % of service exports) in Kazakhstan and Balance of Payment (as % of service exports) in Sierra Leone?
Your response must be concise. -1.72. In the year 2009, what is the difference between the Balance of Payment (as % of service exports) in Kazakhstan and Balance of Payment (as % of service exports) in Sweden?
Provide a succinct answer. 7.33. In the year 2009, what is the difference between the Balance of Payment (as % of service exports) in Madagascar and Balance of Payment (as % of service exports) in Sierra Leone?
Ensure brevity in your answer.  4.42. In the year 2009, what is the difference between the Balance of Payment (as % of service exports) in Madagascar and Balance of Payment (as % of service exports) in Sweden?
Give a very brief answer. 13.48. In the year 2009, what is the difference between the Balance of Payment (as % of service exports) of Sierra Leone and Balance of Payment (as % of service exports) of Sweden?
Ensure brevity in your answer.  9.06. In the year 2010, what is the difference between the Balance of Payment (as % of service exports) of Kazakhstan and Balance of Payment (as % of service exports) of Madagascar?
Your answer should be very brief. -5.93. In the year 2010, what is the difference between the Balance of Payment (as % of service exports) of Kazakhstan and Balance of Payment (as % of service exports) of Sierra Leone?
Provide a succinct answer. -21.12. In the year 2010, what is the difference between the Balance of Payment (as % of service exports) in Kazakhstan and Balance of Payment (as % of service exports) in Sweden?
Your answer should be very brief. 8.49. In the year 2010, what is the difference between the Balance of Payment (as % of service exports) in Madagascar and Balance of Payment (as % of service exports) in Sierra Leone?
Your answer should be compact. -15.19. In the year 2010, what is the difference between the Balance of Payment (as % of service exports) in Madagascar and Balance of Payment (as % of service exports) in Sweden?
Your answer should be compact. 14.42. In the year 2010, what is the difference between the Balance of Payment (as % of service exports) in Sierra Leone and Balance of Payment (as % of service exports) in Sweden?
Give a very brief answer. 29.61. In the year 2011, what is the difference between the Balance of Payment (as % of service exports) in Kazakhstan and Balance of Payment (as % of service exports) in Madagascar?
Your answer should be compact. -12.7. In the year 2011, what is the difference between the Balance of Payment (as % of service exports) in Kazakhstan and Balance of Payment (as % of service exports) in Sierra Leone?
Give a very brief answer. -0.41. In the year 2011, what is the difference between the Balance of Payment (as % of service exports) of Kazakhstan and Balance of Payment (as % of service exports) of Sweden?
Your answer should be compact. 11.18. In the year 2011, what is the difference between the Balance of Payment (as % of service exports) in Madagascar and Balance of Payment (as % of service exports) in Sierra Leone?
Keep it short and to the point. 12.29. In the year 2011, what is the difference between the Balance of Payment (as % of service exports) of Madagascar and Balance of Payment (as % of service exports) of Sweden?
Keep it short and to the point. 23.88. In the year 2011, what is the difference between the Balance of Payment (as % of service exports) of Sierra Leone and Balance of Payment (as % of service exports) of Sweden?
Give a very brief answer. 11.59. In the year 2012, what is the difference between the Balance of Payment (as % of service exports) in Kazakhstan and Balance of Payment (as % of service exports) in Madagascar?
Your answer should be compact. -14.6. In the year 2012, what is the difference between the Balance of Payment (as % of service exports) in Kazakhstan and Balance of Payment (as % of service exports) in Sierra Leone?
Provide a short and direct response. 1.58. In the year 2012, what is the difference between the Balance of Payment (as % of service exports) of Kazakhstan and Balance of Payment (as % of service exports) of Sweden?
Your answer should be very brief. 10.68. In the year 2012, what is the difference between the Balance of Payment (as % of service exports) of Madagascar and Balance of Payment (as % of service exports) of Sierra Leone?
Make the answer very short. 16.18. In the year 2012, what is the difference between the Balance of Payment (as % of service exports) of Madagascar and Balance of Payment (as % of service exports) of Sweden?
Ensure brevity in your answer.  25.28. In the year 2012, what is the difference between the Balance of Payment (as % of service exports) of Sierra Leone and Balance of Payment (as % of service exports) of Sweden?
Offer a terse response. 9.1. In the year 2013, what is the difference between the Balance of Payment (as % of service exports) of Kazakhstan and Balance of Payment (as % of service exports) of Madagascar?
Your response must be concise. -17.68. In the year 2013, what is the difference between the Balance of Payment (as % of service exports) of Kazakhstan and Balance of Payment (as % of service exports) of Sierra Leone?
Make the answer very short. -6.41. In the year 2013, what is the difference between the Balance of Payment (as % of service exports) in Kazakhstan and Balance of Payment (as % of service exports) in Sweden?
Offer a very short reply. 11.89. In the year 2013, what is the difference between the Balance of Payment (as % of service exports) in Madagascar and Balance of Payment (as % of service exports) in Sierra Leone?
Make the answer very short. 11.27. In the year 2013, what is the difference between the Balance of Payment (as % of service exports) of Madagascar and Balance of Payment (as % of service exports) of Sweden?
Provide a succinct answer. 29.57. In the year 2013, what is the difference between the Balance of Payment (as % of service exports) of Sierra Leone and Balance of Payment (as % of service exports) of Sweden?
Offer a very short reply. 18.3. What is the ratio of the Balance of Payment (as % of service exports) in Kazakhstan in 2006 to that in 2007?
Your answer should be compact. 1.06. What is the ratio of the Balance of Payment (as % of service exports) of Madagascar in 2006 to that in 2007?
Provide a short and direct response. 1.28. What is the ratio of the Balance of Payment (as % of service exports) in Sierra Leone in 2006 to that in 2007?
Keep it short and to the point. 1.12. What is the ratio of the Balance of Payment (as % of service exports) in Sweden in 2006 to that in 2007?
Your answer should be very brief. 1.01. What is the ratio of the Balance of Payment (as % of service exports) in Kazakhstan in 2006 to that in 2008?
Your answer should be compact. 1.33. What is the ratio of the Balance of Payment (as % of service exports) in Madagascar in 2006 to that in 2008?
Provide a succinct answer. 1.29. What is the ratio of the Balance of Payment (as % of service exports) of Sierra Leone in 2006 to that in 2008?
Give a very brief answer. 1. What is the ratio of the Balance of Payment (as % of service exports) of Sweden in 2006 to that in 2008?
Make the answer very short. 1.14. What is the ratio of the Balance of Payment (as % of service exports) of Kazakhstan in 2006 to that in 2009?
Make the answer very short. 1.33. What is the ratio of the Balance of Payment (as % of service exports) in Madagascar in 2006 to that in 2009?
Make the answer very short. 1.17. What is the ratio of the Balance of Payment (as % of service exports) in Sierra Leone in 2006 to that in 2009?
Make the answer very short. 2.28. What is the ratio of the Balance of Payment (as % of service exports) of Sweden in 2006 to that in 2009?
Your answer should be compact. 1.23. What is the ratio of the Balance of Payment (as % of service exports) in Kazakhstan in 2006 to that in 2010?
Keep it short and to the point. 1.28. What is the ratio of the Balance of Payment (as % of service exports) in Madagascar in 2006 to that in 2010?
Give a very brief answer. 1.14. What is the ratio of the Balance of Payment (as % of service exports) in Sierra Leone in 2006 to that in 2010?
Make the answer very short. 1.26. What is the ratio of the Balance of Payment (as % of service exports) of Sweden in 2006 to that in 2010?
Keep it short and to the point. 1.25. What is the ratio of the Balance of Payment (as % of service exports) of Kazakhstan in 2006 to that in 2011?
Keep it short and to the point. 1.12. What is the ratio of the Balance of Payment (as % of service exports) in Madagascar in 2006 to that in 2011?
Your answer should be very brief. 0.85. What is the ratio of the Balance of Payment (as % of service exports) of Sierra Leone in 2006 to that in 2011?
Provide a short and direct response. 2.03. What is the ratio of the Balance of Payment (as % of service exports) of Sweden in 2006 to that in 2011?
Ensure brevity in your answer.  1.19. What is the ratio of the Balance of Payment (as % of service exports) of Kazakhstan in 2006 to that in 2012?
Give a very brief answer. 1.12. What is the ratio of the Balance of Payment (as % of service exports) of Madagascar in 2006 to that in 2012?
Keep it short and to the point. 0.81. What is the ratio of the Balance of Payment (as % of service exports) of Sierra Leone in 2006 to that in 2012?
Provide a short and direct response. 2.18. What is the ratio of the Balance of Payment (as % of service exports) in Sweden in 2006 to that in 2012?
Your answer should be compact. 1.16. What is the ratio of the Balance of Payment (as % of service exports) of Kazakhstan in 2006 to that in 2013?
Give a very brief answer. 1.13. What is the ratio of the Balance of Payment (as % of service exports) of Madagascar in 2006 to that in 2013?
Offer a very short reply. 0.76. What is the ratio of the Balance of Payment (as % of service exports) in Sierra Leone in 2006 to that in 2013?
Give a very brief answer. 1.69. What is the ratio of the Balance of Payment (as % of service exports) in Sweden in 2006 to that in 2013?
Offer a terse response. 1.26. What is the ratio of the Balance of Payment (as % of service exports) of Kazakhstan in 2007 to that in 2008?
Your response must be concise. 1.26. What is the ratio of the Balance of Payment (as % of service exports) in Sierra Leone in 2007 to that in 2008?
Your answer should be compact. 0.89. What is the ratio of the Balance of Payment (as % of service exports) of Sweden in 2007 to that in 2008?
Ensure brevity in your answer.  1.13. What is the ratio of the Balance of Payment (as % of service exports) in Kazakhstan in 2007 to that in 2009?
Your answer should be compact. 1.26. What is the ratio of the Balance of Payment (as % of service exports) of Madagascar in 2007 to that in 2009?
Provide a short and direct response. 0.91. What is the ratio of the Balance of Payment (as % of service exports) of Sierra Leone in 2007 to that in 2009?
Make the answer very short. 2.03. What is the ratio of the Balance of Payment (as % of service exports) of Sweden in 2007 to that in 2009?
Give a very brief answer. 1.22. What is the ratio of the Balance of Payment (as % of service exports) in Kazakhstan in 2007 to that in 2010?
Your answer should be compact. 1.21. What is the ratio of the Balance of Payment (as % of service exports) in Madagascar in 2007 to that in 2010?
Provide a short and direct response. 0.89. What is the ratio of the Balance of Payment (as % of service exports) of Sierra Leone in 2007 to that in 2010?
Your answer should be very brief. 1.12. What is the ratio of the Balance of Payment (as % of service exports) of Sweden in 2007 to that in 2010?
Your response must be concise. 1.24. What is the ratio of the Balance of Payment (as % of service exports) of Kazakhstan in 2007 to that in 2011?
Offer a terse response. 1.06. What is the ratio of the Balance of Payment (as % of service exports) in Madagascar in 2007 to that in 2011?
Offer a very short reply. 0.66. What is the ratio of the Balance of Payment (as % of service exports) in Sierra Leone in 2007 to that in 2011?
Provide a short and direct response. 1.81. What is the ratio of the Balance of Payment (as % of service exports) in Sweden in 2007 to that in 2011?
Keep it short and to the point. 1.18. What is the ratio of the Balance of Payment (as % of service exports) in Kazakhstan in 2007 to that in 2012?
Your answer should be compact. 1.06. What is the ratio of the Balance of Payment (as % of service exports) of Madagascar in 2007 to that in 2012?
Offer a very short reply. 0.63. What is the ratio of the Balance of Payment (as % of service exports) of Sierra Leone in 2007 to that in 2012?
Make the answer very short. 1.94. What is the ratio of the Balance of Payment (as % of service exports) of Sweden in 2007 to that in 2012?
Ensure brevity in your answer.  1.14. What is the ratio of the Balance of Payment (as % of service exports) of Kazakhstan in 2007 to that in 2013?
Your answer should be compact. 1.07. What is the ratio of the Balance of Payment (as % of service exports) of Madagascar in 2007 to that in 2013?
Make the answer very short. 0.59. What is the ratio of the Balance of Payment (as % of service exports) in Sierra Leone in 2007 to that in 2013?
Your answer should be very brief. 1.5. What is the ratio of the Balance of Payment (as % of service exports) of Sweden in 2007 to that in 2013?
Give a very brief answer. 1.25. What is the ratio of the Balance of Payment (as % of service exports) in Madagascar in 2008 to that in 2009?
Give a very brief answer. 0.91. What is the ratio of the Balance of Payment (as % of service exports) of Sierra Leone in 2008 to that in 2009?
Ensure brevity in your answer.  2.27. What is the ratio of the Balance of Payment (as % of service exports) of Sweden in 2008 to that in 2009?
Your answer should be compact. 1.08. What is the ratio of the Balance of Payment (as % of service exports) in Madagascar in 2008 to that in 2010?
Your response must be concise. 0.89. What is the ratio of the Balance of Payment (as % of service exports) in Sierra Leone in 2008 to that in 2010?
Offer a terse response. 1.26. What is the ratio of the Balance of Payment (as % of service exports) in Sweden in 2008 to that in 2010?
Make the answer very short. 1.1. What is the ratio of the Balance of Payment (as % of service exports) in Kazakhstan in 2008 to that in 2011?
Make the answer very short. 0.85. What is the ratio of the Balance of Payment (as % of service exports) of Madagascar in 2008 to that in 2011?
Offer a very short reply. 0.66. What is the ratio of the Balance of Payment (as % of service exports) of Sierra Leone in 2008 to that in 2011?
Provide a short and direct response. 2.03. What is the ratio of the Balance of Payment (as % of service exports) in Sweden in 2008 to that in 2011?
Provide a succinct answer. 1.04. What is the ratio of the Balance of Payment (as % of service exports) of Kazakhstan in 2008 to that in 2012?
Keep it short and to the point. 0.84. What is the ratio of the Balance of Payment (as % of service exports) of Madagascar in 2008 to that in 2012?
Provide a short and direct response. 0.63. What is the ratio of the Balance of Payment (as % of service exports) in Sierra Leone in 2008 to that in 2012?
Offer a terse response. 2.18. What is the ratio of the Balance of Payment (as % of service exports) in Sweden in 2008 to that in 2012?
Offer a terse response. 1.01. What is the ratio of the Balance of Payment (as % of service exports) of Kazakhstan in 2008 to that in 2013?
Provide a succinct answer. 0.85. What is the ratio of the Balance of Payment (as % of service exports) of Madagascar in 2008 to that in 2013?
Make the answer very short. 0.59. What is the ratio of the Balance of Payment (as % of service exports) in Sierra Leone in 2008 to that in 2013?
Provide a short and direct response. 1.68. What is the ratio of the Balance of Payment (as % of service exports) of Sweden in 2008 to that in 2013?
Provide a succinct answer. 1.1. What is the ratio of the Balance of Payment (as % of service exports) of Kazakhstan in 2009 to that in 2010?
Keep it short and to the point. 0.96. What is the ratio of the Balance of Payment (as % of service exports) of Madagascar in 2009 to that in 2010?
Keep it short and to the point. 0.98. What is the ratio of the Balance of Payment (as % of service exports) in Sierra Leone in 2009 to that in 2010?
Your answer should be compact. 0.55. What is the ratio of the Balance of Payment (as % of service exports) in Sweden in 2009 to that in 2010?
Keep it short and to the point. 1.01. What is the ratio of the Balance of Payment (as % of service exports) of Kazakhstan in 2009 to that in 2011?
Make the answer very short. 0.84. What is the ratio of the Balance of Payment (as % of service exports) of Madagascar in 2009 to that in 2011?
Offer a terse response. 0.73. What is the ratio of the Balance of Payment (as % of service exports) of Sierra Leone in 2009 to that in 2011?
Your response must be concise. 0.89. What is the ratio of the Balance of Payment (as % of service exports) of Sweden in 2009 to that in 2011?
Provide a succinct answer. 0.97. What is the ratio of the Balance of Payment (as % of service exports) in Kazakhstan in 2009 to that in 2012?
Provide a succinct answer. 0.84. What is the ratio of the Balance of Payment (as % of service exports) in Madagascar in 2009 to that in 2012?
Offer a terse response. 0.7. What is the ratio of the Balance of Payment (as % of service exports) of Sierra Leone in 2009 to that in 2012?
Ensure brevity in your answer.  0.96. What is the ratio of the Balance of Payment (as % of service exports) of Sweden in 2009 to that in 2012?
Offer a terse response. 0.94. What is the ratio of the Balance of Payment (as % of service exports) in Kazakhstan in 2009 to that in 2013?
Provide a short and direct response. 0.85. What is the ratio of the Balance of Payment (as % of service exports) in Madagascar in 2009 to that in 2013?
Keep it short and to the point. 0.65. What is the ratio of the Balance of Payment (as % of service exports) of Sierra Leone in 2009 to that in 2013?
Your response must be concise. 0.74. What is the ratio of the Balance of Payment (as % of service exports) in Sweden in 2009 to that in 2013?
Offer a terse response. 1.02. What is the ratio of the Balance of Payment (as % of service exports) in Kazakhstan in 2010 to that in 2011?
Keep it short and to the point. 0.88. What is the ratio of the Balance of Payment (as % of service exports) of Madagascar in 2010 to that in 2011?
Provide a succinct answer. 0.75. What is the ratio of the Balance of Payment (as % of service exports) in Sierra Leone in 2010 to that in 2011?
Provide a succinct answer. 1.61. What is the ratio of the Balance of Payment (as % of service exports) in Sweden in 2010 to that in 2011?
Offer a very short reply. 0.95. What is the ratio of the Balance of Payment (as % of service exports) of Kazakhstan in 2010 to that in 2012?
Offer a terse response. 0.87. What is the ratio of the Balance of Payment (as % of service exports) of Madagascar in 2010 to that in 2012?
Offer a very short reply. 0.71. What is the ratio of the Balance of Payment (as % of service exports) of Sierra Leone in 2010 to that in 2012?
Keep it short and to the point. 1.73. What is the ratio of the Balance of Payment (as % of service exports) in Sweden in 2010 to that in 2012?
Ensure brevity in your answer.  0.92. What is the ratio of the Balance of Payment (as % of service exports) in Kazakhstan in 2010 to that in 2013?
Ensure brevity in your answer.  0.88. What is the ratio of the Balance of Payment (as % of service exports) in Madagascar in 2010 to that in 2013?
Provide a succinct answer. 0.67. What is the ratio of the Balance of Payment (as % of service exports) of Sierra Leone in 2010 to that in 2013?
Your response must be concise. 1.33. What is the ratio of the Balance of Payment (as % of service exports) in Kazakhstan in 2011 to that in 2012?
Your answer should be very brief. 1. What is the ratio of the Balance of Payment (as % of service exports) in Madagascar in 2011 to that in 2012?
Provide a short and direct response. 0.95. What is the ratio of the Balance of Payment (as % of service exports) of Sierra Leone in 2011 to that in 2012?
Make the answer very short. 1.07. What is the ratio of the Balance of Payment (as % of service exports) of Sweden in 2011 to that in 2012?
Make the answer very short. 0.97. What is the ratio of the Balance of Payment (as % of service exports) of Kazakhstan in 2011 to that in 2013?
Offer a very short reply. 1.01. What is the ratio of the Balance of Payment (as % of service exports) in Madagascar in 2011 to that in 2013?
Make the answer very short. 0.89. What is the ratio of the Balance of Payment (as % of service exports) of Sierra Leone in 2011 to that in 2013?
Your answer should be very brief. 0.83. What is the ratio of the Balance of Payment (as % of service exports) of Sweden in 2011 to that in 2013?
Ensure brevity in your answer.  1.06. What is the ratio of the Balance of Payment (as % of service exports) of Kazakhstan in 2012 to that in 2013?
Offer a terse response. 1.01. What is the ratio of the Balance of Payment (as % of service exports) in Madagascar in 2012 to that in 2013?
Offer a very short reply. 0.94. What is the ratio of the Balance of Payment (as % of service exports) of Sierra Leone in 2012 to that in 2013?
Keep it short and to the point. 0.77. What is the ratio of the Balance of Payment (as % of service exports) in Sweden in 2012 to that in 2013?
Your answer should be compact. 1.09. What is the difference between the highest and the second highest Balance of Payment (as % of service exports) of Kazakhstan?
Your answer should be compact. 1.7. What is the difference between the highest and the second highest Balance of Payment (as % of service exports) in Madagascar?
Provide a succinct answer. 2.87. What is the difference between the highest and the second highest Balance of Payment (as % of service exports) of Sierra Leone?
Give a very brief answer. 0.21. What is the difference between the highest and the second highest Balance of Payment (as % of service exports) of Sweden?
Provide a short and direct response. 0.2. What is the difference between the highest and the lowest Balance of Payment (as % of service exports) of Kazakhstan?
Give a very brief answer. 7.84. What is the difference between the highest and the lowest Balance of Payment (as % of service exports) of Madagascar?
Keep it short and to the point. 18.51. What is the difference between the highest and the lowest Balance of Payment (as % of service exports) in Sierra Leone?
Make the answer very short. 32.29. What is the difference between the highest and the lowest Balance of Payment (as % of service exports) of Sweden?
Your answer should be very brief. 4.08. 